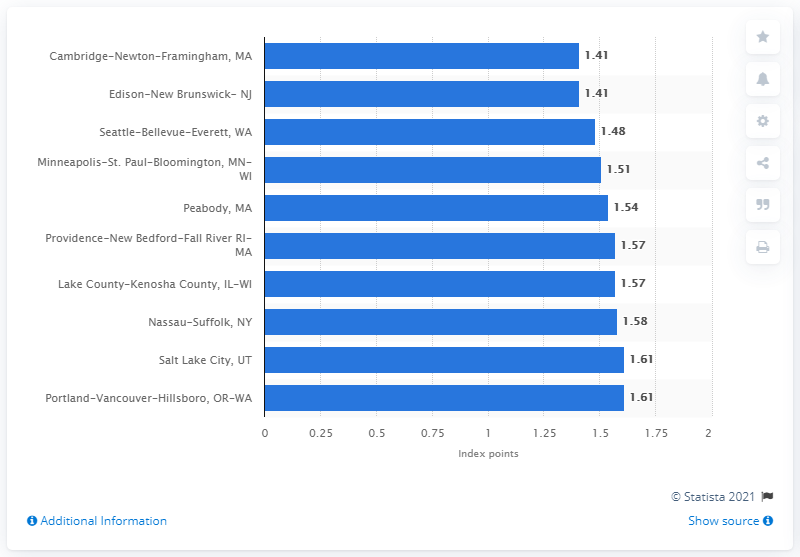List a handful of essential elements in this visual. The Peace Index value for Cambridge-Newton-Framingham was 1.41. 